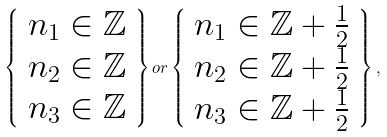Convert formula to latex. <formula><loc_0><loc_0><loc_500><loc_500>\left \{ \begin{array} { l } n _ { 1 } \in \mathbb { Z } \\ n _ { 2 } \in \mathbb { Z } \\ n _ { 3 } \in \mathbb { Z } \end{array} \right \} o r \left \{ \begin{array} { l } n _ { 1 } \in \mathbb { Z } + \frac { 1 } { 2 } \\ n _ { 2 } \in \mathbb { Z } + \frac { 1 } { 2 } \\ n _ { 3 } \in \mathbb { Z } + \frac { 1 } { 2 } \end{array} \right \} ,</formula> 